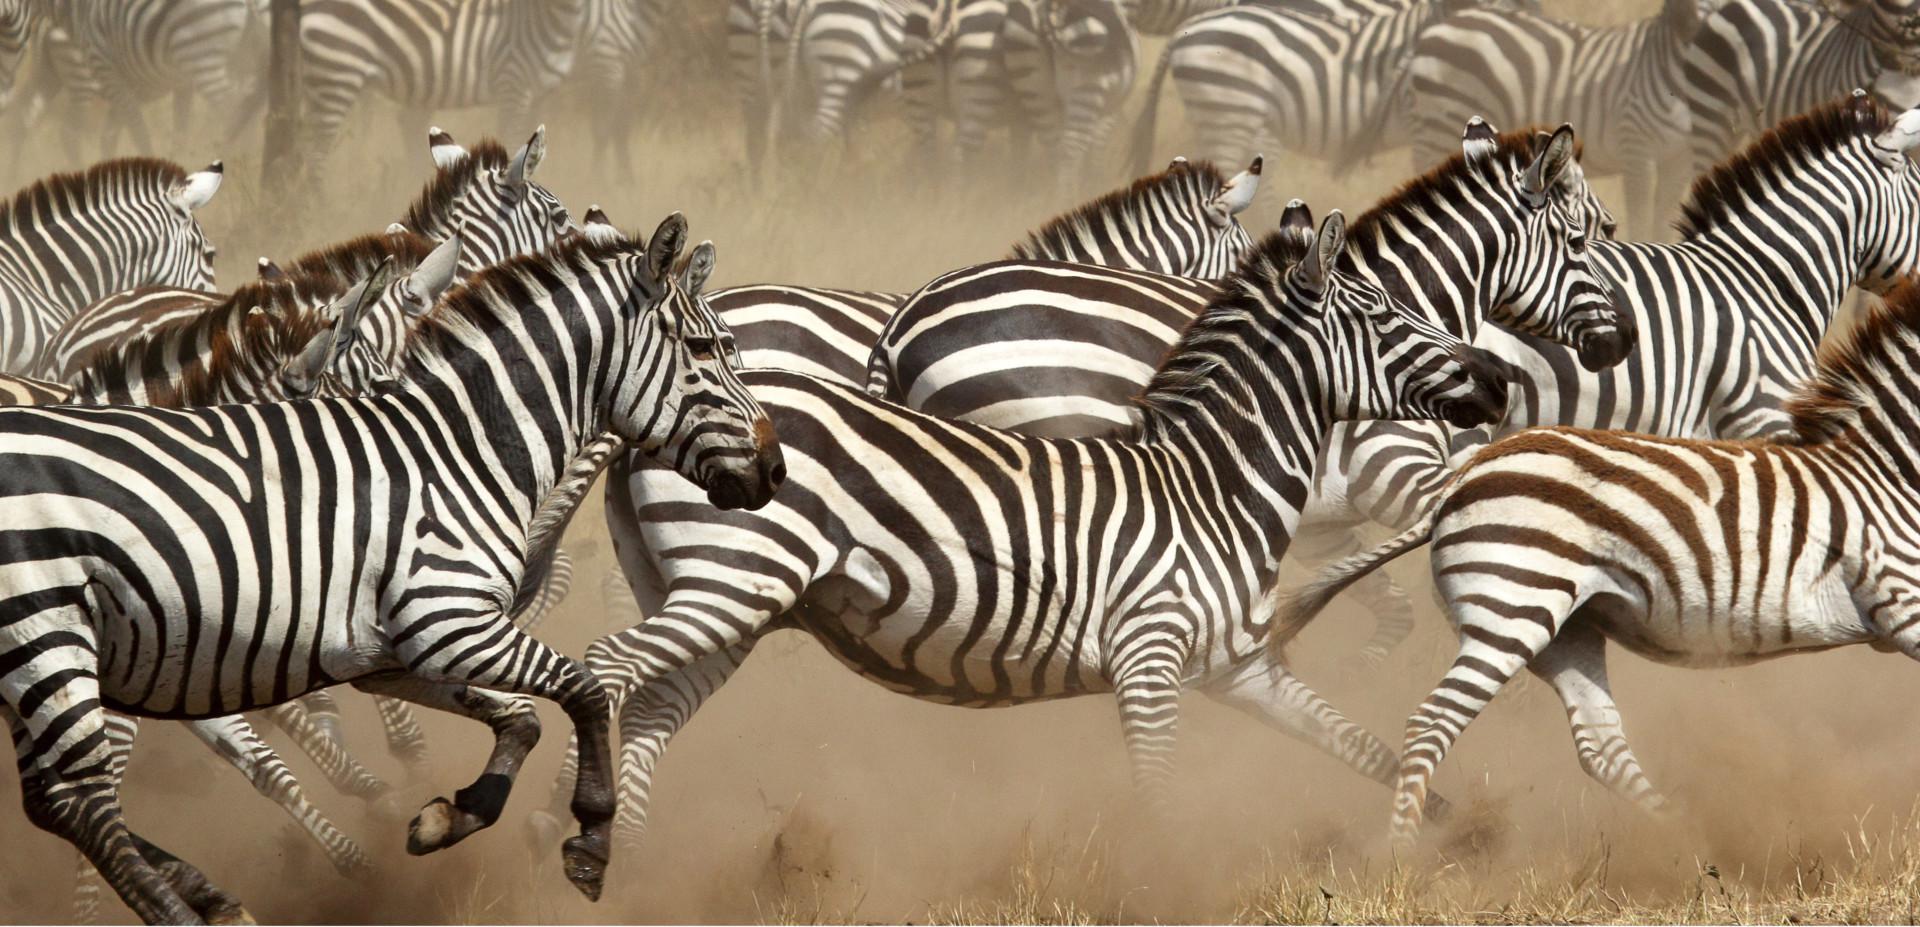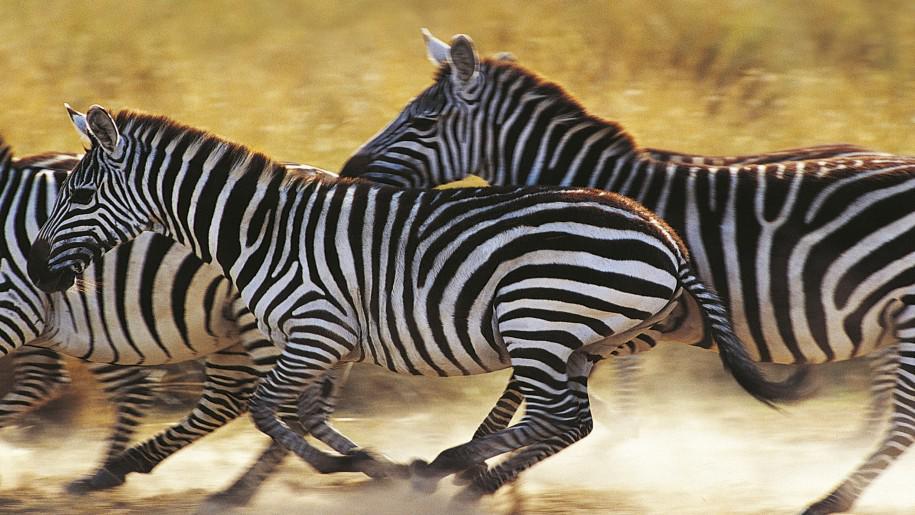The first image is the image on the left, the second image is the image on the right. For the images shown, is this caption "Nine or fewer zebras are present." true? Answer yes or no. No. The first image is the image on the left, the second image is the image on the right. For the images displayed, is the sentence "All the zebras are running." factually correct? Answer yes or no. Yes. 